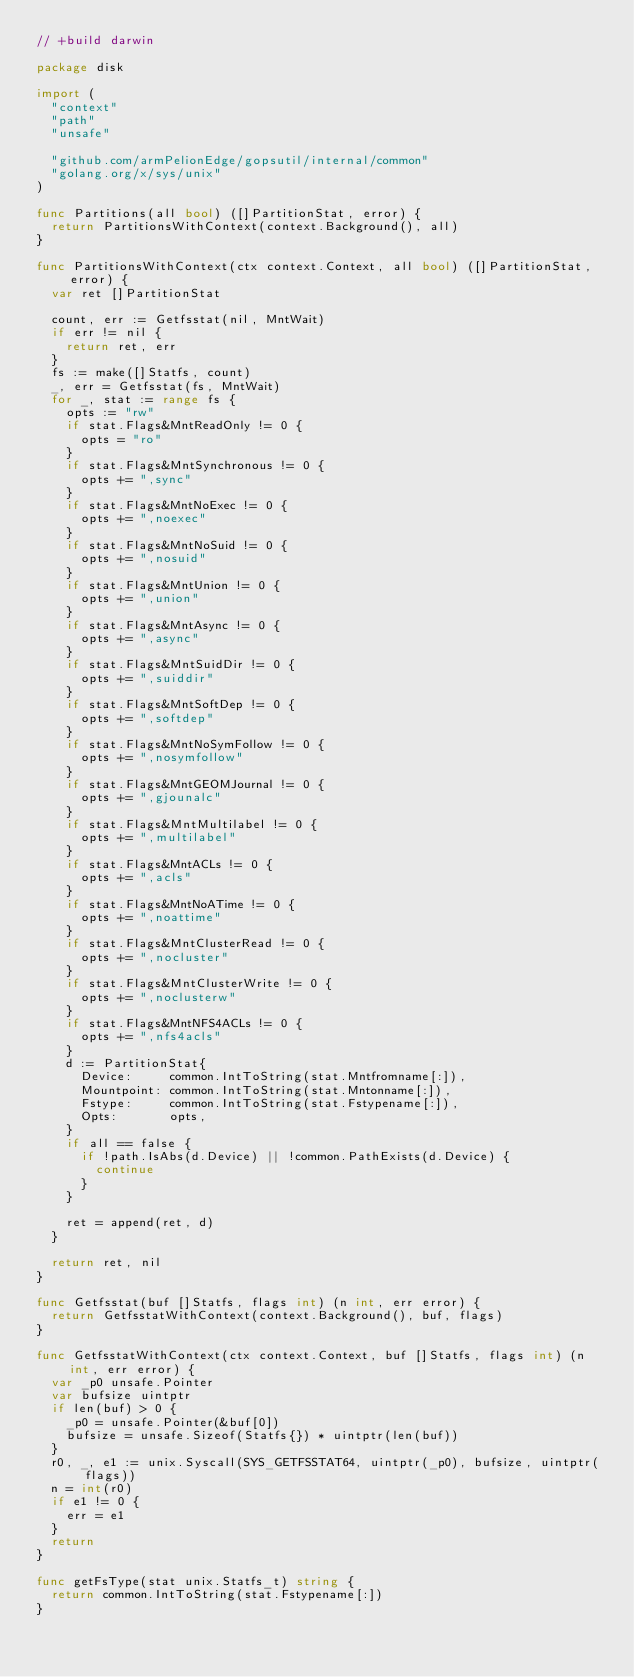Convert code to text. <code><loc_0><loc_0><loc_500><loc_500><_Go_>// +build darwin

package disk

import (
	"context"
	"path"
	"unsafe"

	"github.com/armPelionEdge/gopsutil/internal/common"
	"golang.org/x/sys/unix"
)

func Partitions(all bool) ([]PartitionStat, error) {
	return PartitionsWithContext(context.Background(), all)
}

func PartitionsWithContext(ctx context.Context, all bool) ([]PartitionStat, error) {
	var ret []PartitionStat

	count, err := Getfsstat(nil, MntWait)
	if err != nil {
		return ret, err
	}
	fs := make([]Statfs, count)
	_, err = Getfsstat(fs, MntWait)
	for _, stat := range fs {
		opts := "rw"
		if stat.Flags&MntReadOnly != 0 {
			opts = "ro"
		}
		if stat.Flags&MntSynchronous != 0 {
			opts += ",sync"
		}
		if stat.Flags&MntNoExec != 0 {
			opts += ",noexec"
		}
		if stat.Flags&MntNoSuid != 0 {
			opts += ",nosuid"
		}
		if stat.Flags&MntUnion != 0 {
			opts += ",union"
		}
		if stat.Flags&MntAsync != 0 {
			opts += ",async"
		}
		if stat.Flags&MntSuidDir != 0 {
			opts += ",suiddir"
		}
		if stat.Flags&MntSoftDep != 0 {
			opts += ",softdep"
		}
		if stat.Flags&MntNoSymFollow != 0 {
			opts += ",nosymfollow"
		}
		if stat.Flags&MntGEOMJournal != 0 {
			opts += ",gjounalc"
		}
		if stat.Flags&MntMultilabel != 0 {
			opts += ",multilabel"
		}
		if stat.Flags&MntACLs != 0 {
			opts += ",acls"
		}
		if stat.Flags&MntNoATime != 0 {
			opts += ",noattime"
		}
		if stat.Flags&MntClusterRead != 0 {
			opts += ",nocluster"
		}
		if stat.Flags&MntClusterWrite != 0 {
			opts += ",noclusterw"
		}
		if stat.Flags&MntNFS4ACLs != 0 {
			opts += ",nfs4acls"
		}
		d := PartitionStat{
			Device:     common.IntToString(stat.Mntfromname[:]),
			Mountpoint: common.IntToString(stat.Mntonname[:]),
			Fstype:     common.IntToString(stat.Fstypename[:]),
			Opts:       opts,
		}
		if all == false {
			if !path.IsAbs(d.Device) || !common.PathExists(d.Device) {
				continue
			}
		}

		ret = append(ret, d)
	}

	return ret, nil
}

func Getfsstat(buf []Statfs, flags int) (n int, err error) {
	return GetfsstatWithContext(context.Background(), buf, flags)
}

func GetfsstatWithContext(ctx context.Context, buf []Statfs, flags int) (n int, err error) {
	var _p0 unsafe.Pointer
	var bufsize uintptr
	if len(buf) > 0 {
		_p0 = unsafe.Pointer(&buf[0])
		bufsize = unsafe.Sizeof(Statfs{}) * uintptr(len(buf))
	}
	r0, _, e1 := unix.Syscall(SYS_GETFSSTAT64, uintptr(_p0), bufsize, uintptr(flags))
	n = int(r0)
	if e1 != 0 {
		err = e1
	}
	return
}

func getFsType(stat unix.Statfs_t) string {
	return common.IntToString(stat.Fstypename[:])
}
</code> 